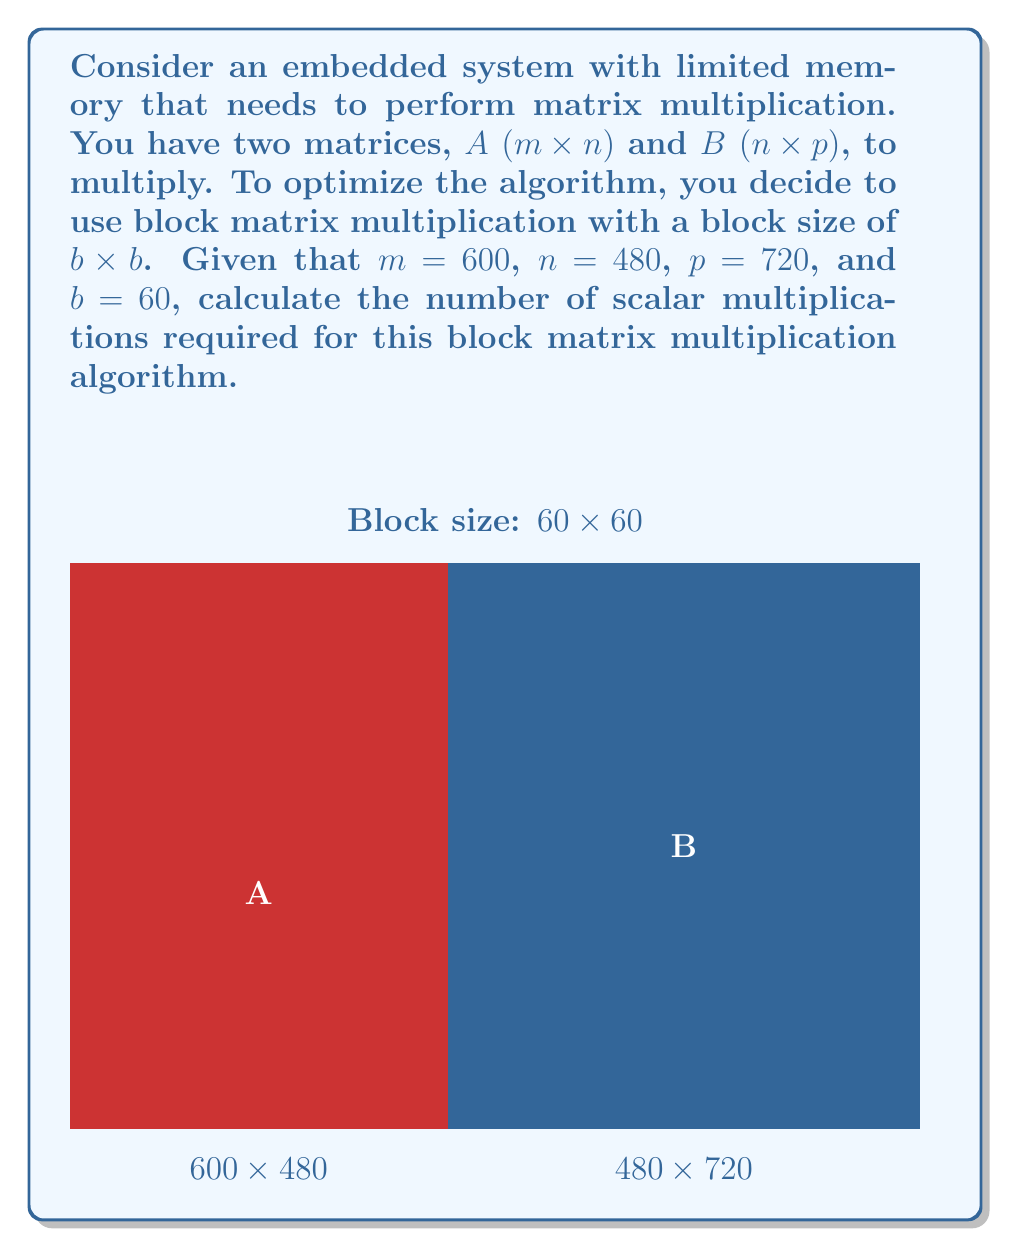Could you help me with this problem? To solve this problem, let's break it down into steps:

1) In block matrix multiplication, we divide the matrices into smaller blocks of size b × b. In this case, b = 60.

2) The number of blocks in each dimension:
   - Matrix A: $\frac{m}{b} \times \frac{n}{b} = \frac{600}{60} \times \frac{480}{60} = 10 \times 8$
   - Matrix B: $\frac{n}{b} \times \frac{p}{b} = \frac{480}{60} \times \frac{720}{60} = 8 \times 12$

3) The resulting matrix C will have dimensions:
   $\frac{m}{b} \times \frac{p}{b} = 10 \times 12$

4) For each block in C, we need to multiply a row of blocks from A with a column of blocks from B. This involves $\frac{n}{b} = 8$ block multiplications.

5) Each block multiplication involves multiplying two 60 × 60 matrices, which requires $60^3 = 216,000$ scalar multiplications.

6) The total number of block multiplications is:
   $\frac{m}{b} \times \frac{p}{b} \times \frac{n}{b} = 10 \times 12 \times 8 = 960$

7) Therefore, the total number of scalar multiplications is:
   $960 \times 216,000 = 207,360,000$

This method reduces the number of multiplications compared to the naive approach, which would require $m \times n \times p = 600 \times 480 \times 720 = 207,360,000$ multiplications.
Answer: 207,360,000 scalar multiplications 